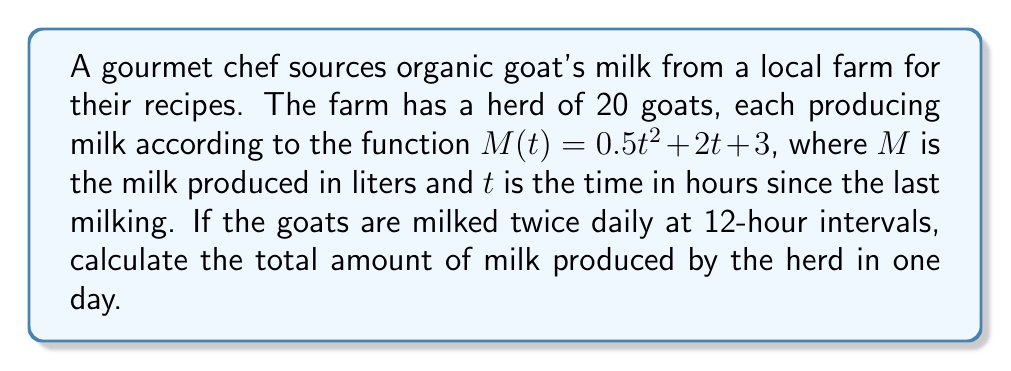Provide a solution to this math problem. Let's approach this step-by-step:

1) First, we need to find the milk produced by one goat in 12 hours:
   $M(12) = 0.5(12)^2 + 2(12) + 3$
   $= 0.5(144) + 24 + 3$
   $= 72 + 24 + 3$
   $= 99$ liters

2) Since the goats are milked twice daily, we multiply this by 2:
   $99 \times 2 = 198$ liters per goat per day

3) Now, we need to calculate this for all 20 goats:
   $198 \times 20 = 3960$ liters

Therefore, the total amount of milk produced by the herd in one day is 3960 liters.
Answer: $3960$ liters 